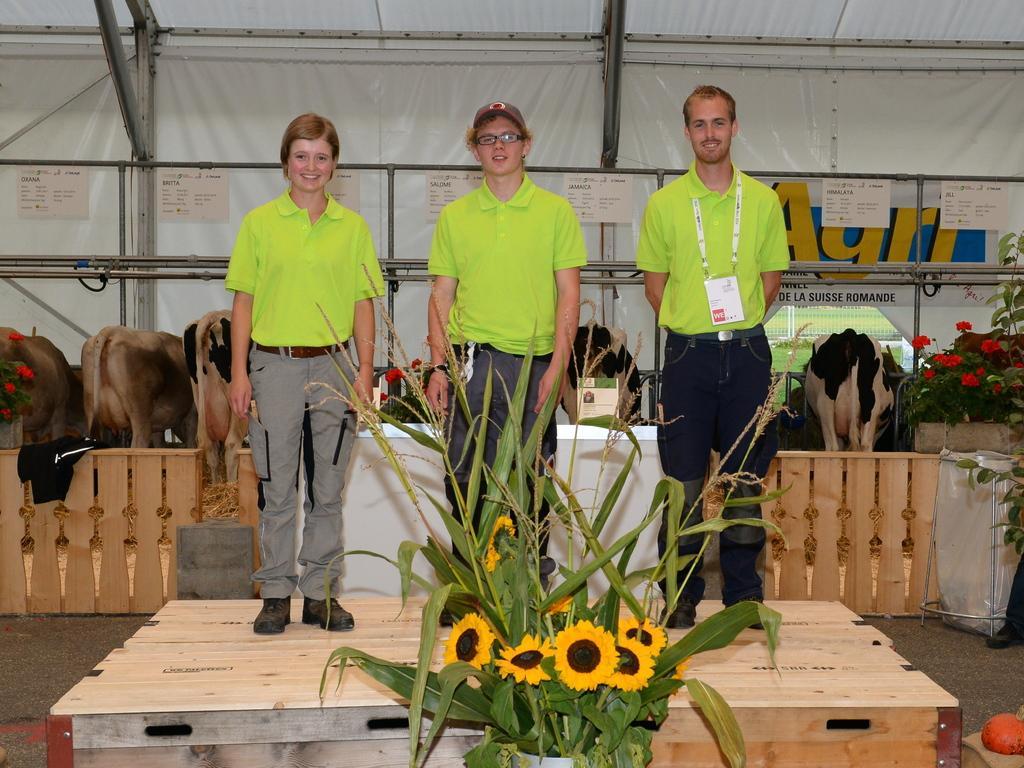In one or two sentences, can you explain what this image depicts? In the image there are leaves and flowers in the foreground, behind the the leaves there is wooden stage and there are three people standing on the wooden stage. Behind them there is a cattle and plants, in the background there are white sheets and in front of the sheets where are rods and some posters. 